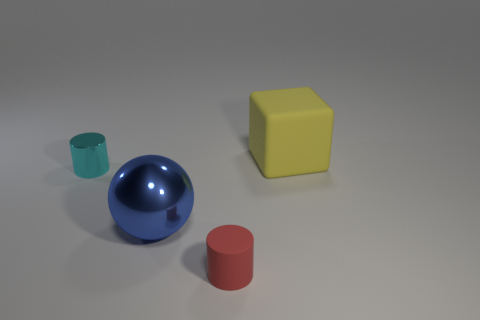Add 2 large blue spheres. How many objects exist? 6 Subtract all spheres. How many objects are left? 3 Add 1 cyan metallic objects. How many cyan metallic objects are left? 2 Add 2 blue shiny objects. How many blue shiny objects exist? 3 Subtract 0 blue cubes. How many objects are left? 4 Subtract all large blue metal things. Subtract all matte cubes. How many objects are left? 2 